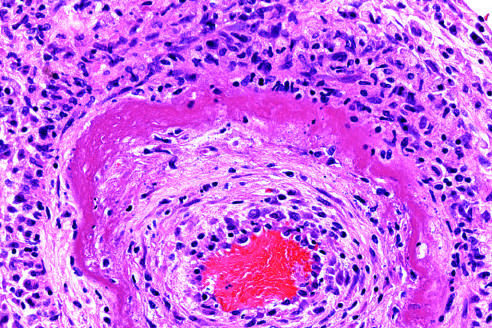what does the wall of the artery show with protein deposition and inflammation?
Answer the question using a single word or phrase. A circumferential bright pink area of necrosis 